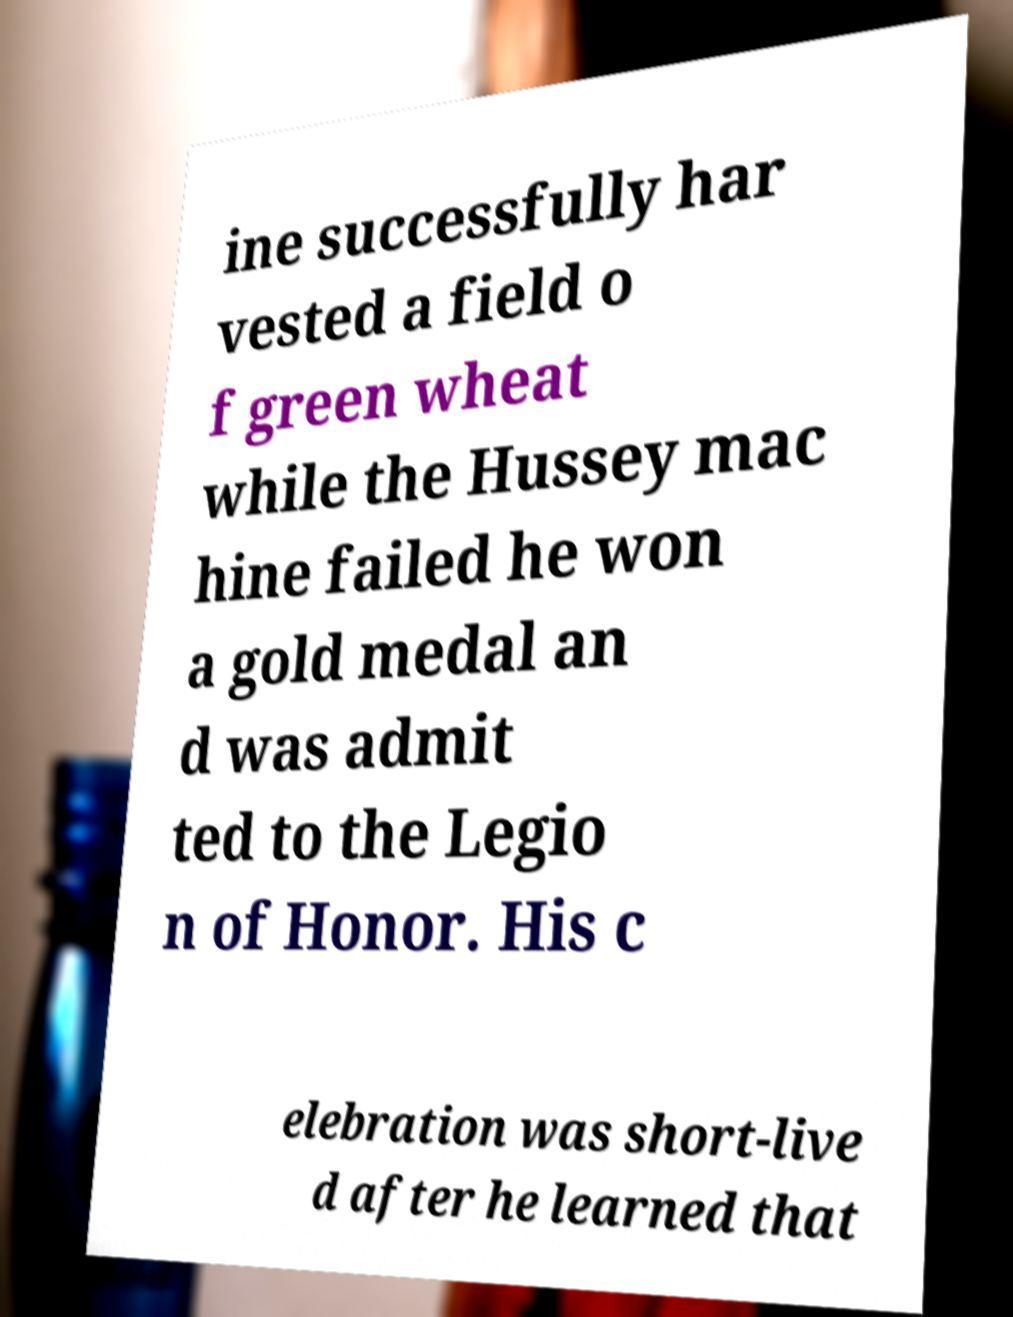Could you extract and type out the text from this image? ine successfully har vested a field o f green wheat while the Hussey mac hine failed he won a gold medal an d was admit ted to the Legio n of Honor. His c elebration was short-live d after he learned that 